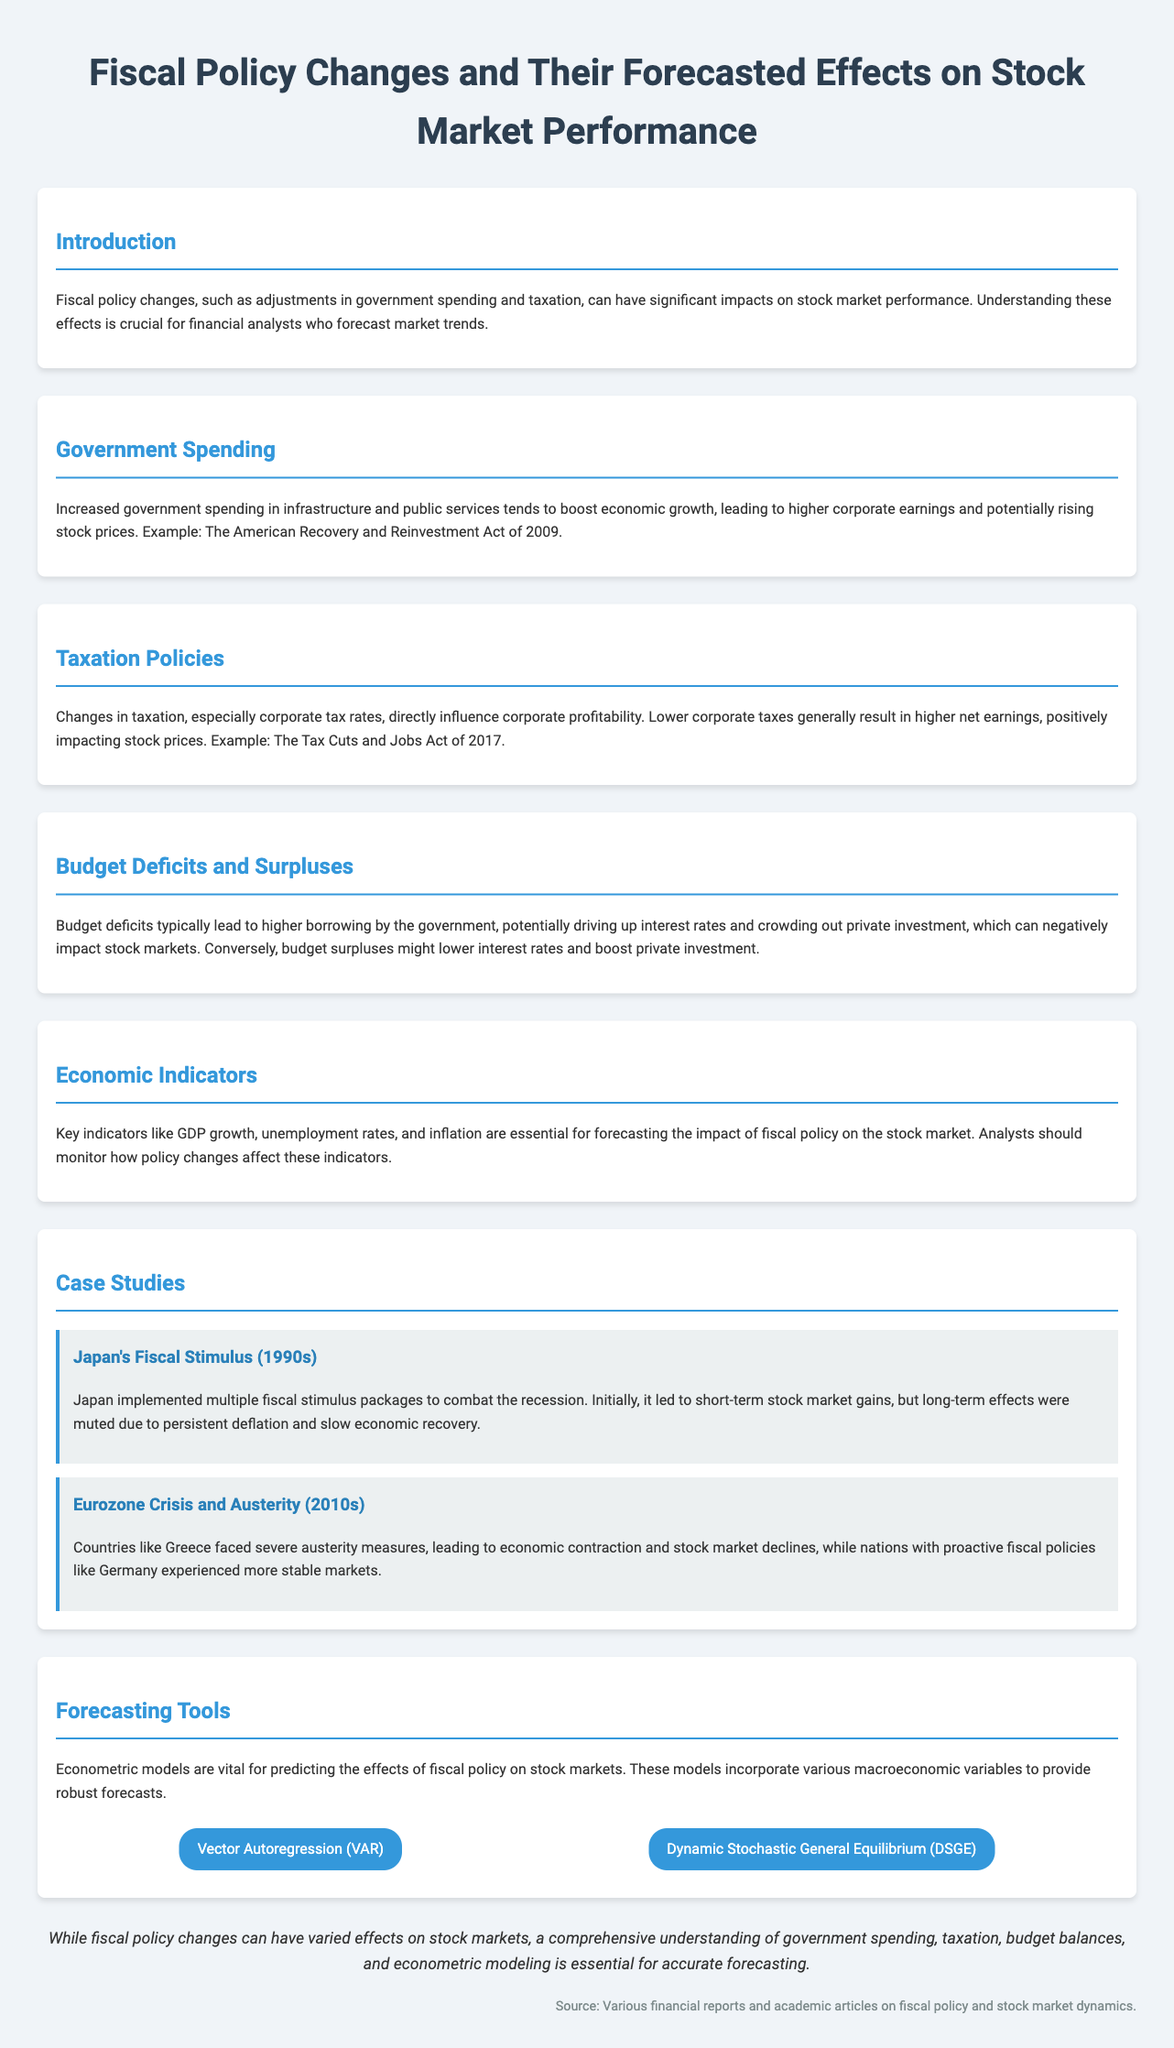what is the title of the infographic? The title of the infographic is displayed prominently at the top of the document.
Answer: Fiscal Policy Changes and Their Forecasted Effects on Stock Market Performance what act is mentioned as an example of increased government spending? The document provides an example of government spending increases citing a specific act.
Answer: The American Recovery and Reinvestment Act of 2009 what fiscal policy change typically leads to higher corporate earnings? The document discusses changes in government actions that impact profitability.
Answer: Increased government spending what is a key indicator for forecasting stock market performance? The infographic lists several indicators essential for forecasting.
Answer: GDP growth which econometric model is mentioned for forecasting effects? The section on forecasting tools describes a specific model used for predictions.
Answer: Vector Autoregression (VAR) what was the effect of Japan's fiscal stimulus in the 1990s? The document summarizes the outcomes of the fiscal stimulus regarding market gains and long-term effects.
Answer: Short-term stock market gains what type of policies did Greece face during the Eurozone Crisis? The case study on Greece provides information about the policies implemented during the crisis.
Answer: Austerity measures what is the forecasted effect of budget surpluses mentioned? The document discusses the impact of budget conditions on economic indicators.
Answer: Lower interest rates which two countries are compared in the Eurozone Crisis case study? The document highlights comparisons between nations to illustrate different responses.
Answer: Greece and Germany 